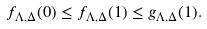Convert formula to latex. <formula><loc_0><loc_0><loc_500><loc_500>f _ { \Lambda , \Delta } ( 0 ) \leq f _ { \Lambda , \Delta } ( 1 ) \leq g _ { \Lambda , \Delta } ( 1 ) .</formula> 